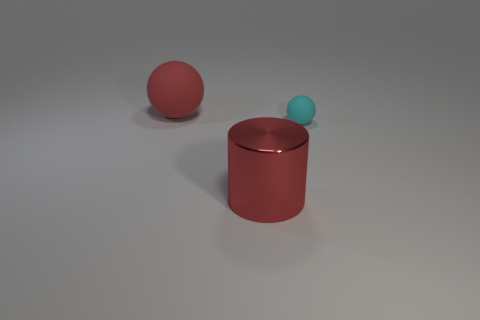Add 2 big brown rubber cubes. How many objects exist? 5 Subtract 1 cylinders. How many cylinders are left? 0 Subtract 0 red cubes. How many objects are left? 3 Subtract all spheres. How many objects are left? 1 Subtract all gray spheres. Subtract all cyan cylinders. How many spheres are left? 2 Subtract all blue cylinders. How many gray balls are left? 0 Subtract all cylinders. Subtract all big red things. How many objects are left? 0 Add 1 large red metallic things. How many large red metallic things are left? 2 Add 2 red cylinders. How many red cylinders exist? 3 